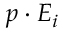<formula> <loc_0><loc_0><loc_500><loc_500>p \cdot E _ { i }</formula> 